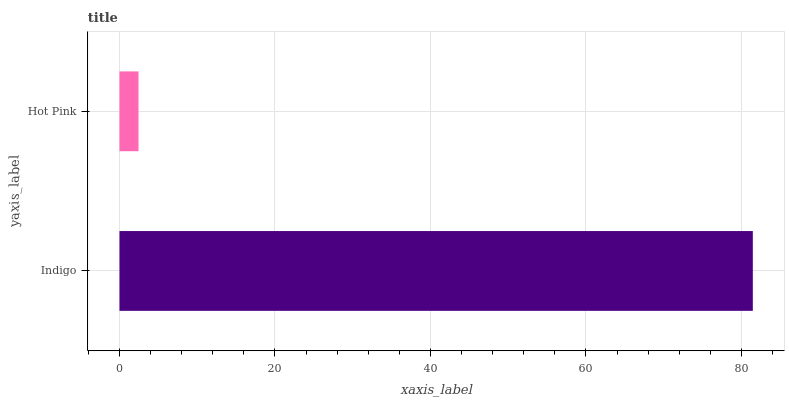Is Hot Pink the minimum?
Answer yes or no. Yes. Is Indigo the maximum?
Answer yes or no. Yes. Is Hot Pink the maximum?
Answer yes or no. No. Is Indigo greater than Hot Pink?
Answer yes or no. Yes. Is Hot Pink less than Indigo?
Answer yes or no. Yes. Is Hot Pink greater than Indigo?
Answer yes or no. No. Is Indigo less than Hot Pink?
Answer yes or no. No. Is Indigo the high median?
Answer yes or no. Yes. Is Hot Pink the low median?
Answer yes or no. Yes. Is Hot Pink the high median?
Answer yes or no. No. Is Indigo the low median?
Answer yes or no. No. 